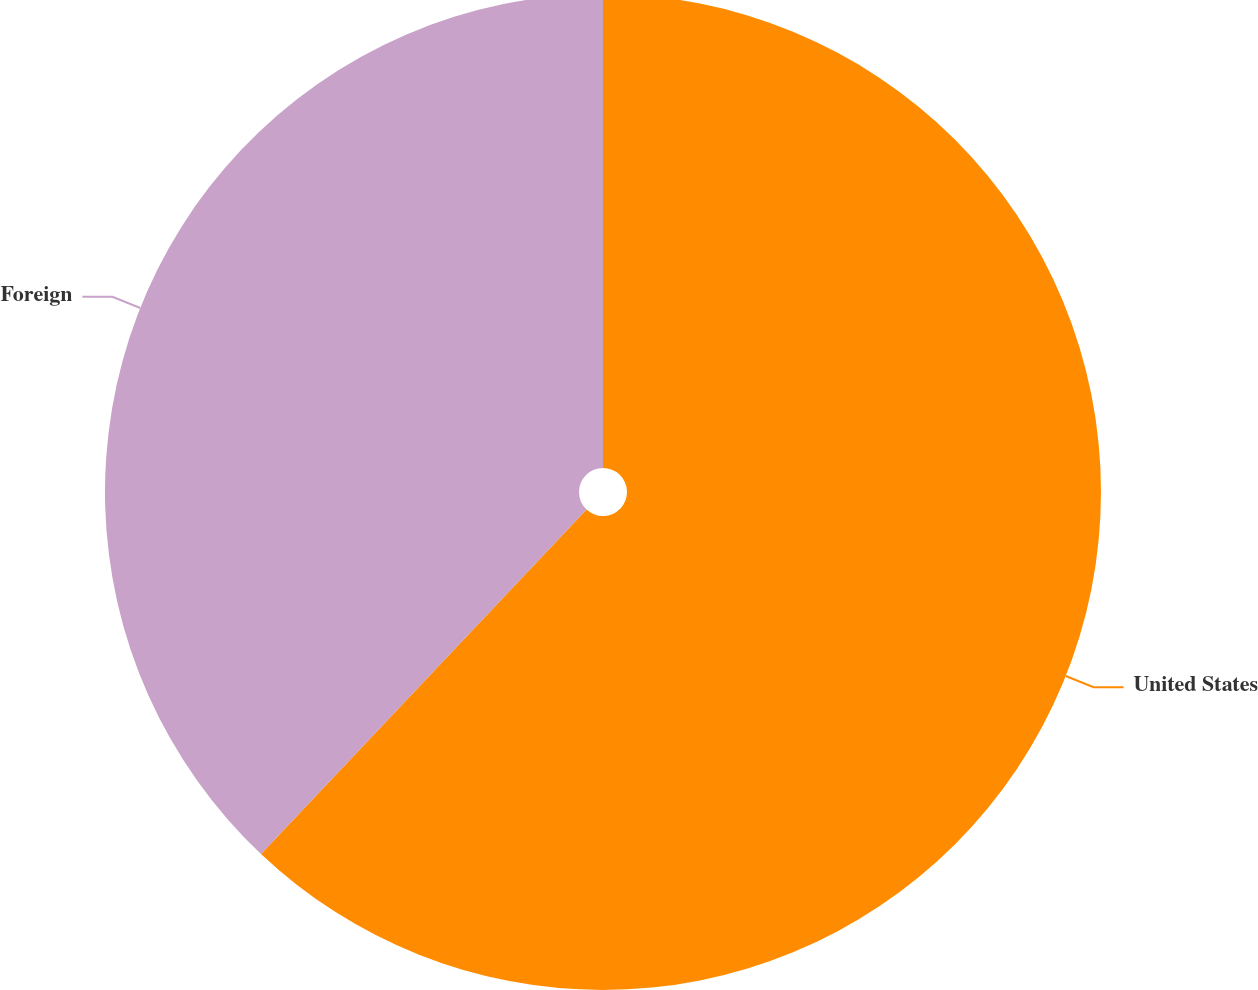Convert chart to OTSL. <chart><loc_0><loc_0><loc_500><loc_500><pie_chart><fcel>United States<fcel>Foreign<nl><fcel>62.05%<fcel>37.95%<nl></chart> 